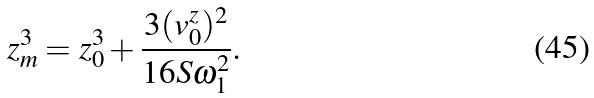Convert formula to latex. <formula><loc_0><loc_0><loc_500><loc_500>z _ { m } ^ { 3 } = z _ { 0 } ^ { 3 } + \frac { 3 ( v _ { 0 } ^ { z } ) ^ { 2 } } { 1 6 S \omega _ { 1 } ^ { 2 } } .</formula> 